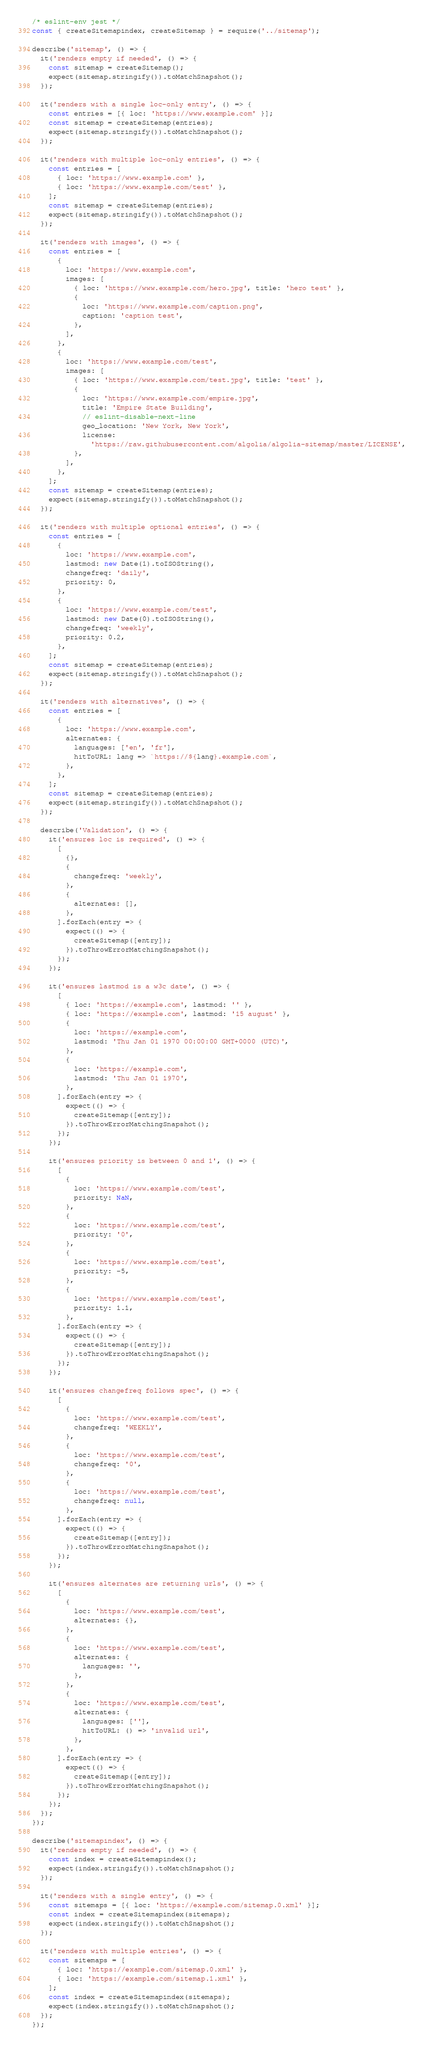Convert code to text. <code><loc_0><loc_0><loc_500><loc_500><_JavaScript_>/* eslint-env jest */
const { createSitemapindex, createSitemap } = require('../sitemap');

describe('sitemap', () => {
  it('renders empty if needed', () => {
    const sitemap = createSitemap();
    expect(sitemap.stringify()).toMatchSnapshot();
  });

  it('renders with a single loc-only entry', () => {
    const entries = [{ loc: 'https://www.example.com' }];
    const sitemap = createSitemap(entries);
    expect(sitemap.stringify()).toMatchSnapshot();
  });

  it('renders with multiple loc-only entries', () => {
    const entries = [
      { loc: 'https://www.example.com' },
      { loc: 'https://www.example.com/test' },
    ];
    const sitemap = createSitemap(entries);
    expect(sitemap.stringify()).toMatchSnapshot();
  });

  it('renders with images', () => {
    const entries = [
      {
        loc: 'https://www.example.com',
        images: [
          { loc: 'https://www.example.com/hero.jpg', title: 'hero test' },
          {
            loc: 'https://www.example.com/caption.png',
            caption: 'caption test',
          },
        ],
      },
      {
        loc: 'https://www.example.com/test',
        images: [
          { loc: 'https://www.example.com/test.jpg', title: 'test' },
          {
            loc: 'https://www.example.com/empire.jpg',
            title: 'Empire State Building',
            // eslint-disable-next-line
            geo_location: 'New York, New York',
            license:
              'https://raw.githubusercontent.com/algolia/algolia-sitemap/master/LICENSE',
          },
        ],
      },
    ];
    const sitemap = createSitemap(entries);
    expect(sitemap.stringify()).toMatchSnapshot();
  });

  it('renders with multiple optional entries', () => {
    const entries = [
      {
        loc: 'https://www.example.com',
        lastmod: new Date(1).toISOString(),
        changefreq: 'daily',
        priority: 0,
      },
      {
        loc: 'https://www.example.com/test',
        lastmod: new Date(0).toISOString(),
        changefreq: 'weekly',
        priority: 0.2,
      },
    ];
    const sitemap = createSitemap(entries);
    expect(sitemap.stringify()).toMatchSnapshot();
  });

  it('renders with alternatives', () => {
    const entries = [
      {
        loc: 'https://www.example.com',
        alternates: {
          languages: ['en', 'fr'],
          hitToURL: lang => `https://${lang}.example.com`,
        },
      },
    ];
    const sitemap = createSitemap(entries);
    expect(sitemap.stringify()).toMatchSnapshot();
  });

  describe('Validation', () => {
    it('ensures loc is required', () => {
      [
        {},
        {
          changefreq: 'weekly',
        },
        {
          alternates: [],
        },
      ].forEach(entry => {
        expect(() => {
          createSitemap([entry]);
        }).toThrowErrorMatchingSnapshot();
      });
    });

    it('ensures lastmod is a w3c date', () => {
      [
        { loc: 'https://example.com', lastmod: '' },
        { loc: 'https://example.com', lastmod: '15 august' },
        {
          loc: 'https://example.com',
          lastmod: 'Thu Jan 01 1970 00:00:00 GMT+0000 (UTC)',
        },
        {
          loc: 'https://example.com',
          lastmod: 'Thu Jan 01 1970',
        },
      ].forEach(entry => {
        expect(() => {
          createSitemap([entry]);
        }).toThrowErrorMatchingSnapshot();
      });
    });

    it('ensures priority is between 0 and 1', () => {
      [
        {
          loc: 'https://www.example.com/test',
          priority: NaN,
        },
        {
          loc: 'https://www.example.com/test',
          priority: '0',
        },
        {
          loc: 'https://www.example.com/test',
          priority: -5,
        },
        {
          loc: 'https://www.example.com/test',
          priority: 1.1,
        },
      ].forEach(entry => {
        expect(() => {
          createSitemap([entry]);
        }).toThrowErrorMatchingSnapshot();
      });
    });

    it('ensures changefreq follows spec', () => {
      [
        {
          loc: 'https://www.example.com/test',
          changefreq: 'WEEKLY',
        },
        {
          loc: 'https://www.example.com/test',
          changefreq: '0',
        },
        {
          loc: 'https://www.example.com/test',
          changefreq: null,
        },
      ].forEach(entry => {
        expect(() => {
          createSitemap([entry]);
        }).toThrowErrorMatchingSnapshot();
      });
    });

    it('ensures alternates are returning urls', () => {
      [
        {
          loc: 'https://www.example.com/test',
          alternates: {},
        },
        {
          loc: 'https://www.example.com/test',
          alternates: {
            languages: '',
          },
        },
        {
          loc: 'https://www.example.com/test',
          alternates: {
            languages: [''],
            hitToURL: () => 'invalid url',
          },
        },
      ].forEach(entry => {
        expect(() => {
          createSitemap([entry]);
        }).toThrowErrorMatchingSnapshot();
      });
    });
  });
});

describe('sitemapindex', () => {
  it('renders empty if needed', () => {
    const index = createSitemapindex();
    expect(index.stringify()).toMatchSnapshot();
  });

  it('renders with a single entry', () => {
    const sitemaps = [{ loc: 'https://example.com/sitemap.0.xml' }];
    const index = createSitemapindex(sitemaps);
    expect(index.stringify()).toMatchSnapshot();
  });

  it('renders with multiple entries', () => {
    const sitemaps = [
      { loc: 'https://example.com/sitemap.0.xml' },
      { loc: 'https://example.com/sitemap.1.xml' },
    ];
    const index = createSitemapindex(sitemaps);
    expect(index.stringify()).toMatchSnapshot();
  });
});
</code> 